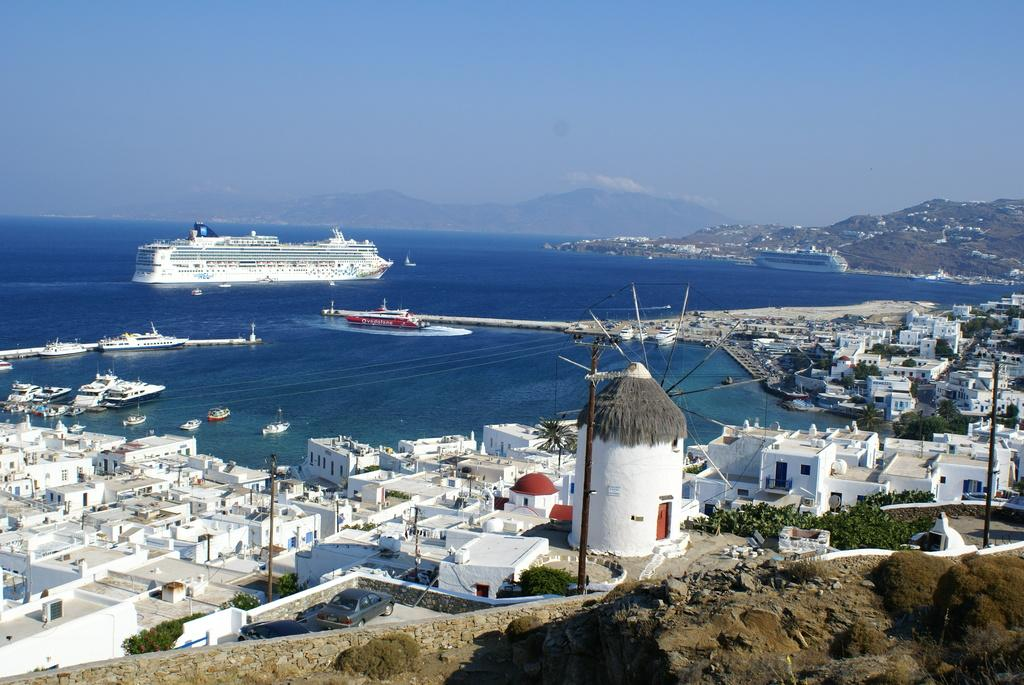What type of body of water is visible in the image? There is a sea in the image. What can be seen floating on the sea? There are ships in the sea. What type of structures are located near the sea? There are houses near the sea. What is visible in the distance behind the sea? There are mountains in the background of the image. What is the color of the sky in the image? The sky is blue in the image. What is the relation between the ships and the houses in the image? There is no specific relation between the ships and the houses mentioned in the image; they are simply two separate elements visible in the scene. 